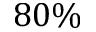<formula> <loc_0><loc_0><loc_500><loc_500>8 0 \%</formula> 